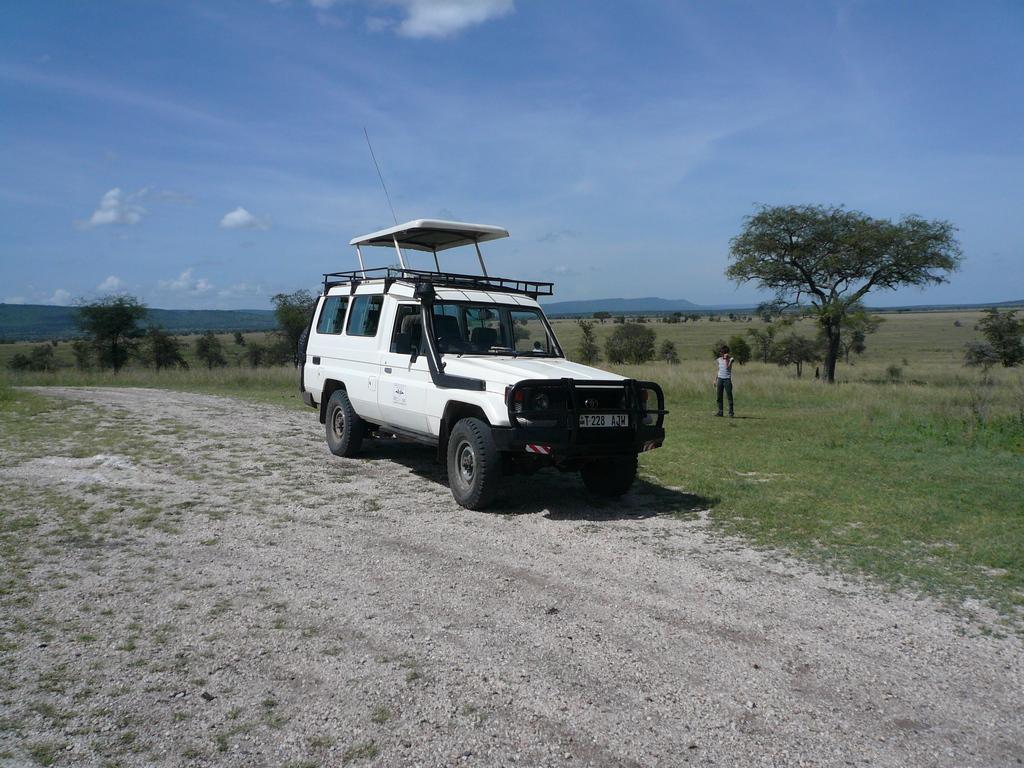Please provide a concise description of this image. In the center of the image we can see a vehicle. On the right there is a person standing. In the background there are trees, hills and sky. At the bottom there is grass. 